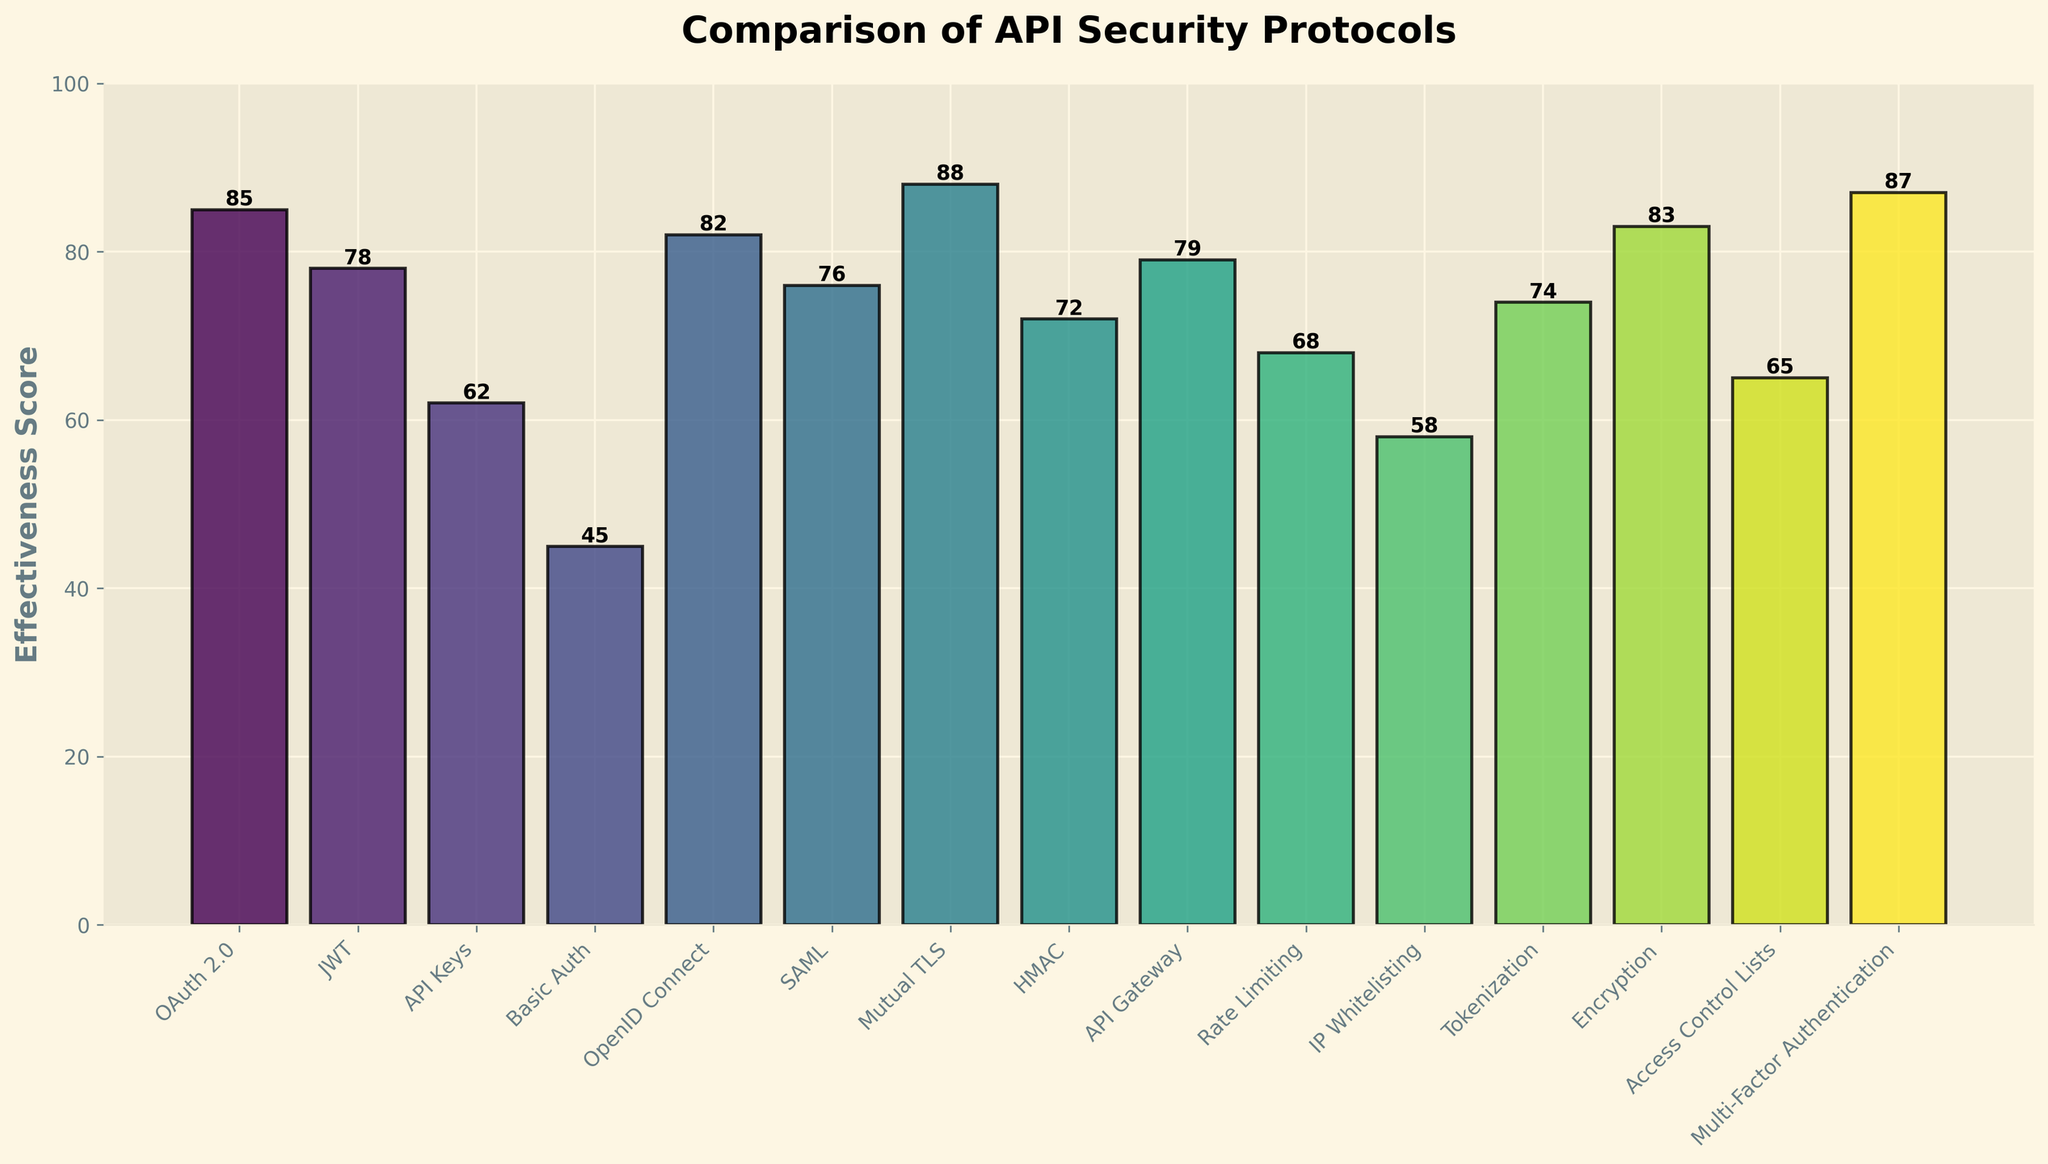Which protocol has the highest effectiveness score? The protocol with the highest effectiveness score can be identified by looking for the tallest bar in the chart. Mutual TLS has the tallest bar with a score of 88.
Answer: Mutual TLS What is the effectiveness score of API Keys? To find the effectiveness score of API Keys, locate its bar and read the value at the top of the bar, which shows 62.
Answer: 62 How many protocols have an effectiveness score of 80 or higher? Count the number of bars with heights corresponding to scores 80 or higher. These are OAuth 2.0 (85), OpenID Connect (82), Mutual TLS (88), Multi-Factor Authentication (87), and Encryption (83). There are 5 protocols in total.
Answer: 5 Which protocol has the lowest effectiveness score? The protocol with the lowest effectiveness score can be identified by finding the shortest bar. Basic Auth has the shortest bar with a score of 45.
Answer: Basic Auth What is the difference between the effectiveness scores of HMAC and API Gateway? Find the heights of the bars for HMAC (72) and API Gateway (79). The difference can be calculated as 79 - 72 = 7.
Answer: 7 What is the average effectiveness score of JWT, SAML, and Tokenization? Find the heights of the bars for JWT (78), SAML (76), and Tokenization (74). Sum the scores and divide by the number of protocols: (78 + 76 + 74) / 3 = 228 / 3 = 76.
Answer: 76 Which has a higher effectiveness score, Rate Limiting or IP Whitelisting? Compare the heights of the bars for Rate Limiting (68) and IP Whitelisting (58). Rate Limiting has a higher score.
Answer: Rate Limiting Are there any protocols with an effectiveness score exactly between 60 and 70? Identify the bars whose heights correspond to scores between 60 and 70. API Keys (62) and Access Control Lists (65) both have scores in this range.
Answer: Yes How much higher is the effectiveness score of Encryption compared to Basic Auth? Find the heights of the bars for Encryption (83) and Basic Auth (45). The difference is 83 - 45 = 38.
Answer: 38 What is the combined effectiveness score of the top three protocols? Identify the top three protocols by their bar heights, which are Mutual TLS (88), Multi-Factor Authentication (87), and OAuth 2.0 (85). Sum their scores: 88 + 87 + 85 = 260.
Answer: 260 